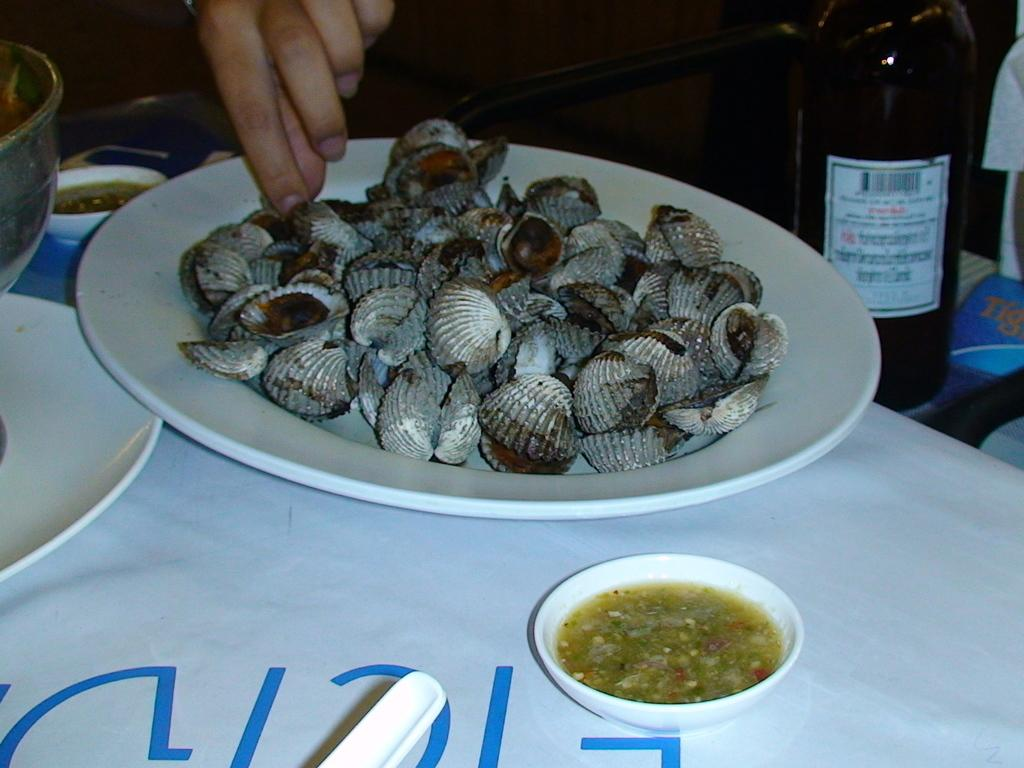What is in the plate that is visible in the image? There are shells in a plate in the image. Who is holding the plate in the image? There is a person holding the plate in the image. What beverage might be served in the image? There is a wine bottle in the image, which suggests that wine might be served. What type of dish might be served in the bowl? There is a bowl in the image, but the contents are not specified. What might be used for drinking in the image? There is a glass in the image, which could be used for drinking. What other objects can be seen on the table in the image? There are additional objects on the table in the image, but their specifics are not mentioned. Where is the snail going in the image? There is no snail present in the image. How does the person lift the heavy objects on the table in the image? There is no mention of heavy objects or lifting in the image. 